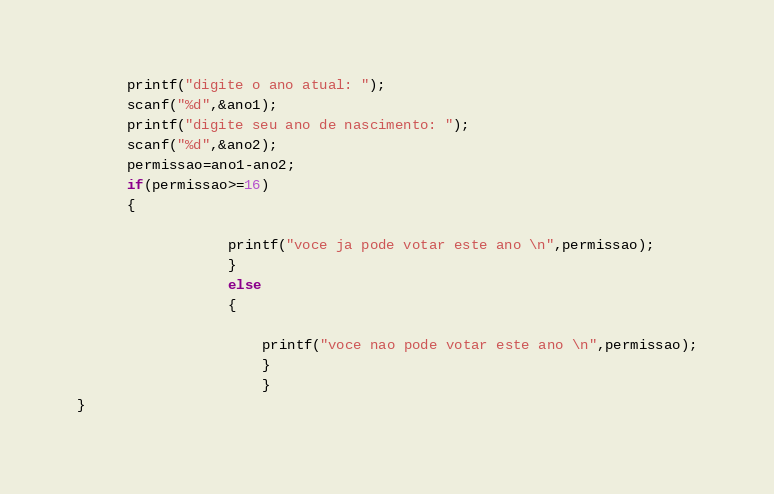<code> <loc_0><loc_0><loc_500><loc_500><_C_>      printf("digite o ano atual: ");
      scanf("%d",&ano1);
      printf("digite seu ano de nascimento: ");
      scanf("%d",&ano2);
      permissao=ano1-ano2;
      if(permissao>=16)
      {
                  
                  printf("voce ja pode votar este ano \n",permissao);
                  }
                  else
                  {
                      
                      printf("voce nao pode votar este ano \n",permissao);
                      }
                      }
}
</code> 